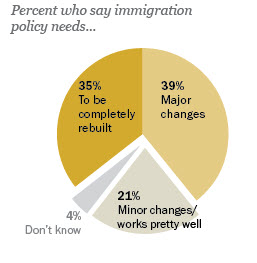Draw attention to some important aspects in this diagram. There are four sectors in the pie chart. The difference between the highest and lowest value is 35. 